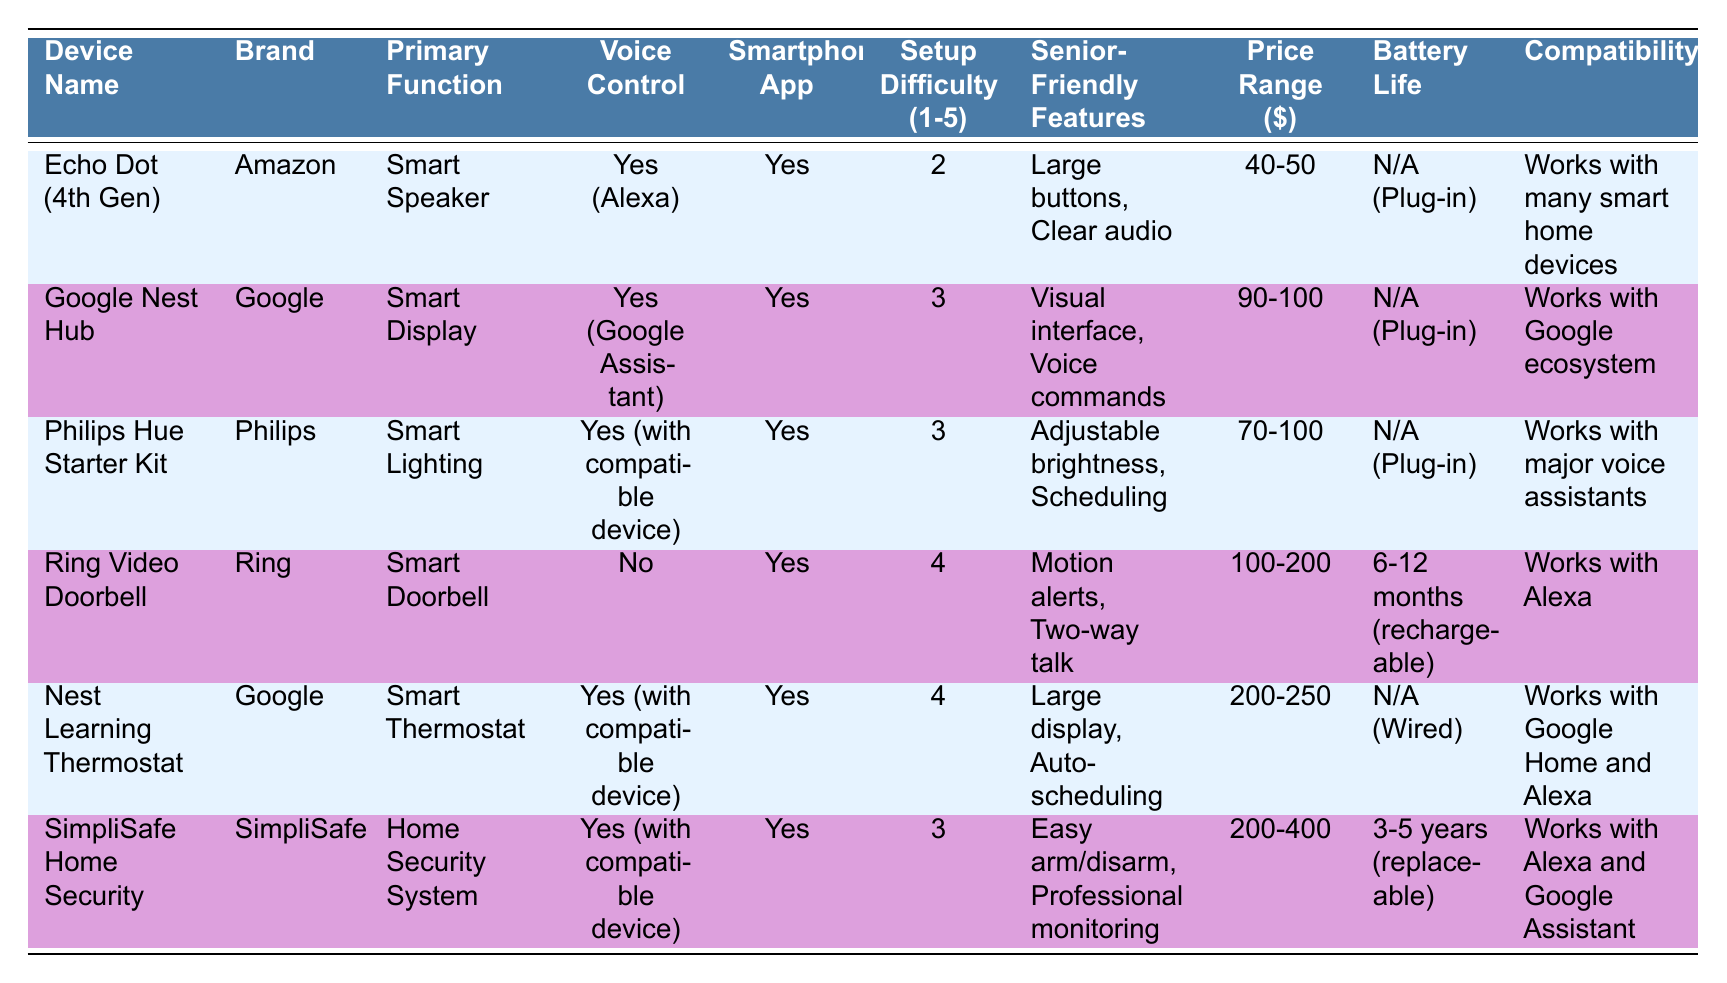What is the primary function of the Echo Dot (4th Gen)? The table lists the primary functions of each device. According to the data, the Echo Dot (4th Gen) has a primary function of being a Smart Speaker.
Answer: Smart Speaker Which device has the highest setup difficulty rating? The setup difficulty ratings are listed from 1 to 5 for each device. Upon reviewing the table, the Ring Video Doorbell and Nest Learning Thermostat both have a rating of 4, which is the highest among all listed devices.
Answer: Ring Video Doorbell and Nest Learning Thermostat Is voice control available for the Philips Hue Starter Kit? The table indicates whether each device has voice control. For the Philips Hue Starter Kit, it states "Yes (with compatible device)", which confirms that voice control is available.
Answer: Yes What is the price range of the SimpliSafe Home Security system? The table shows the price ranges for each device. The price range for the SimpliSafe Home Security system is listed as 200-400 dollars.
Answer: 200-400 How many devices have a setup difficulty rating of 3? The table lists the setup difficulty ratings for all devices. By counting the ratings, we find that three devices—Google Nest Hub, Philips Hue Starter Kit, and SimpliSafe Home Security—have a rating of 3.
Answer: 3 Which brand offers a device with a visual interface, and what is the device name? From the table, the Google Nest Hub is the device with a visual interface, which is noted under its senior-friendly features. The brand is Google.
Answer: Google Nest Hub What is the average price range of the devices that offer voice control? We first extract the price ranges of the devices that offer voice control, which are Echo Dot (40-50), Google Nest Hub (90-100), Philips Hue (70-100), Nest Learning Thermostat (200-250), and SimpliSafe (200-400). Converting these ranges into numerical values yields: 45, 95, 85, 225, and 300, respectively. The average is (45 + 95 + 85 + 225 + 300) / 5 = 150.
Answer: 150 Which device has the longest battery life and what is that battery life? The battery life for each device is listed in the table. The SimpliSafe Home Security system has the longest battery life of 3-5 years as it states it is replaceable.
Answer: 3-5 years Does the Echo Dot (4th Gen) support a smartphone app? The table clearly states whether standalone smartphone apps are available for each device. For the Echo Dot (4th Gen), it is noted as "Yes".
Answer: Yes 